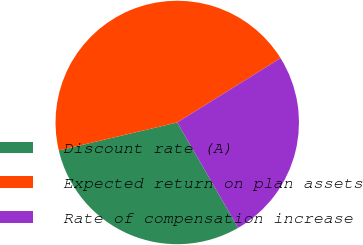Convert chart. <chart><loc_0><loc_0><loc_500><loc_500><pie_chart><fcel>Discount rate (A)<fcel>Expected return on plan assets<fcel>Rate of compensation increase<nl><fcel>29.66%<fcel>44.83%<fcel>25.52%<nl></chart> 